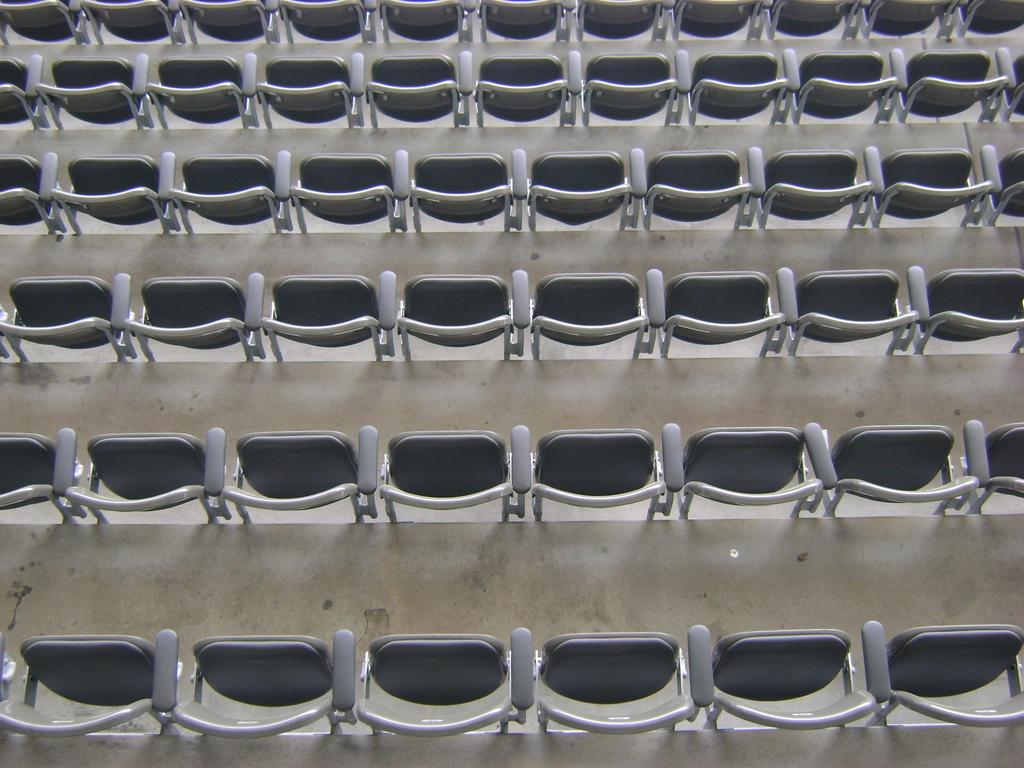What type of structure is present in the image? There are stairs in the image. What type of furniture is present in the image? There are chairs in the image. What type of beast can be seen sitting on the stairs in the image? There is no beast present in the image; it only features stairs and chairs. What type of flowers are visible on the chairs in the image? There are no flowers present in the image; it only features stairs and chairs. 